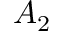Convert formula to latex. <formula><loc_0><loc_0><loc_500><loc_500>A _ { 2 }</formula> 